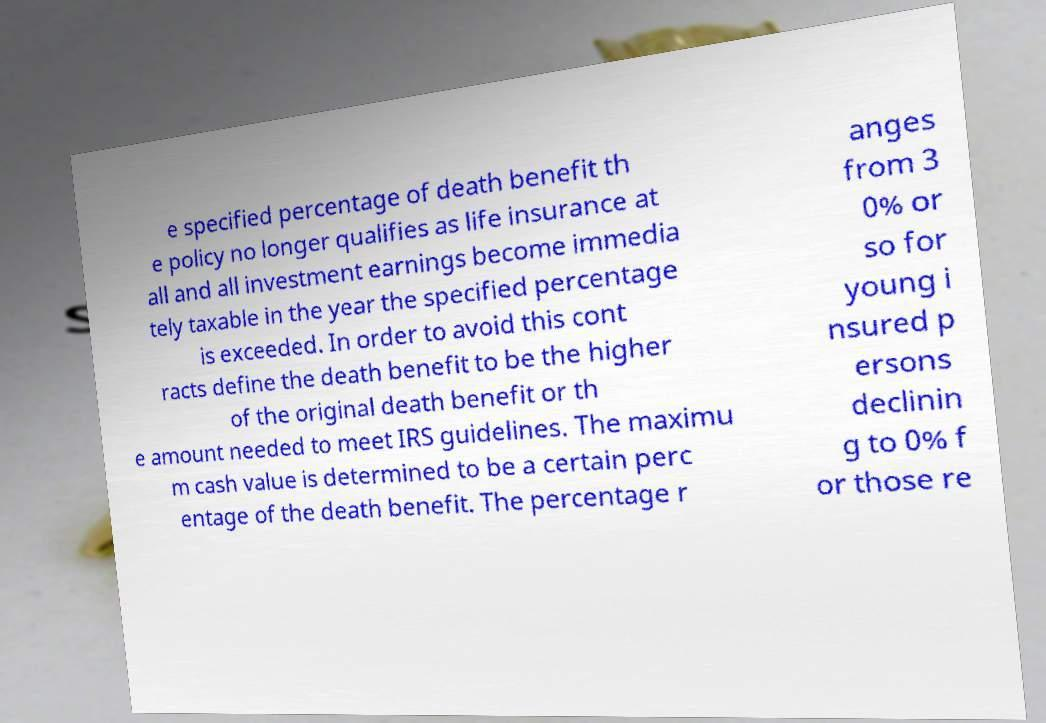There's text embedded in this image that I need extracted. Can you transcribe it verbatim? e specified percentage of death benefit th e policy no longer qualifies as life insurance at all and all investment earnings become immedia tely taxable in the year the specified percentage is exceeded. In order to avoid this cont racts define the death benefit to be the higher of the original death benefit or th e amount needed to meet IRS guidelines. The maximu m cash value is determined to be a certain perc entage of the death benefit. The percentage r anges from 3 0% or so for young i nsured p ersons declinin g to 0% f or those re 